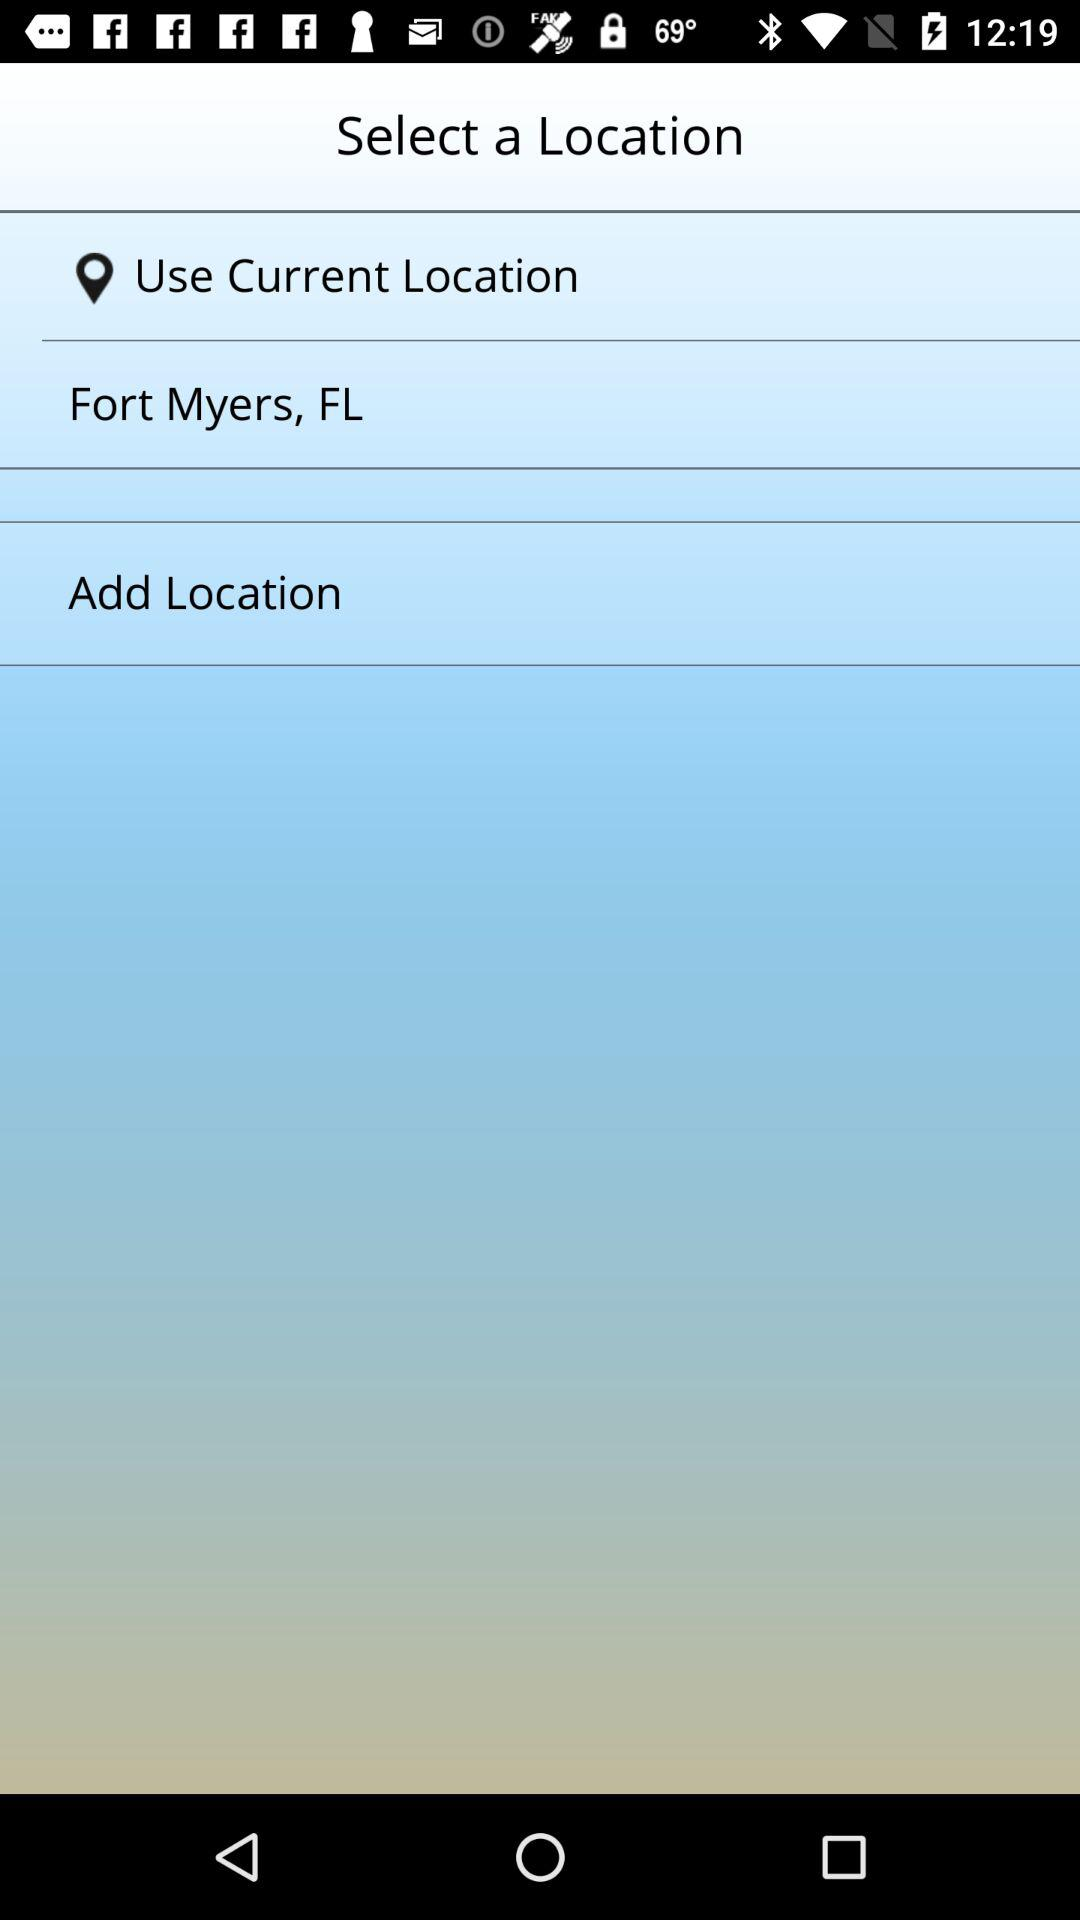How many locations can be selected?
Answer the question using a single word or phrase. 2 